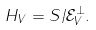<formula> <loc_0><loc_0><loc_500><loc_500>H _ { V } = S / \mathcal { E } _ { V } ^ { \perp } .</formula> 